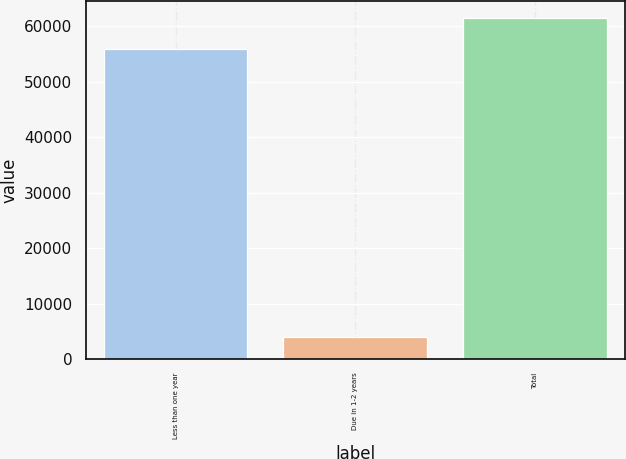<chart> <loc_0><loc_0><loc_500><loc_500><bar_chart><fcel>Less than one year<fcel>Due in 1-2 years<fcel>Total<nl><fcel>55956<fcel>4000<fcel>61551.6<nl></chart> 